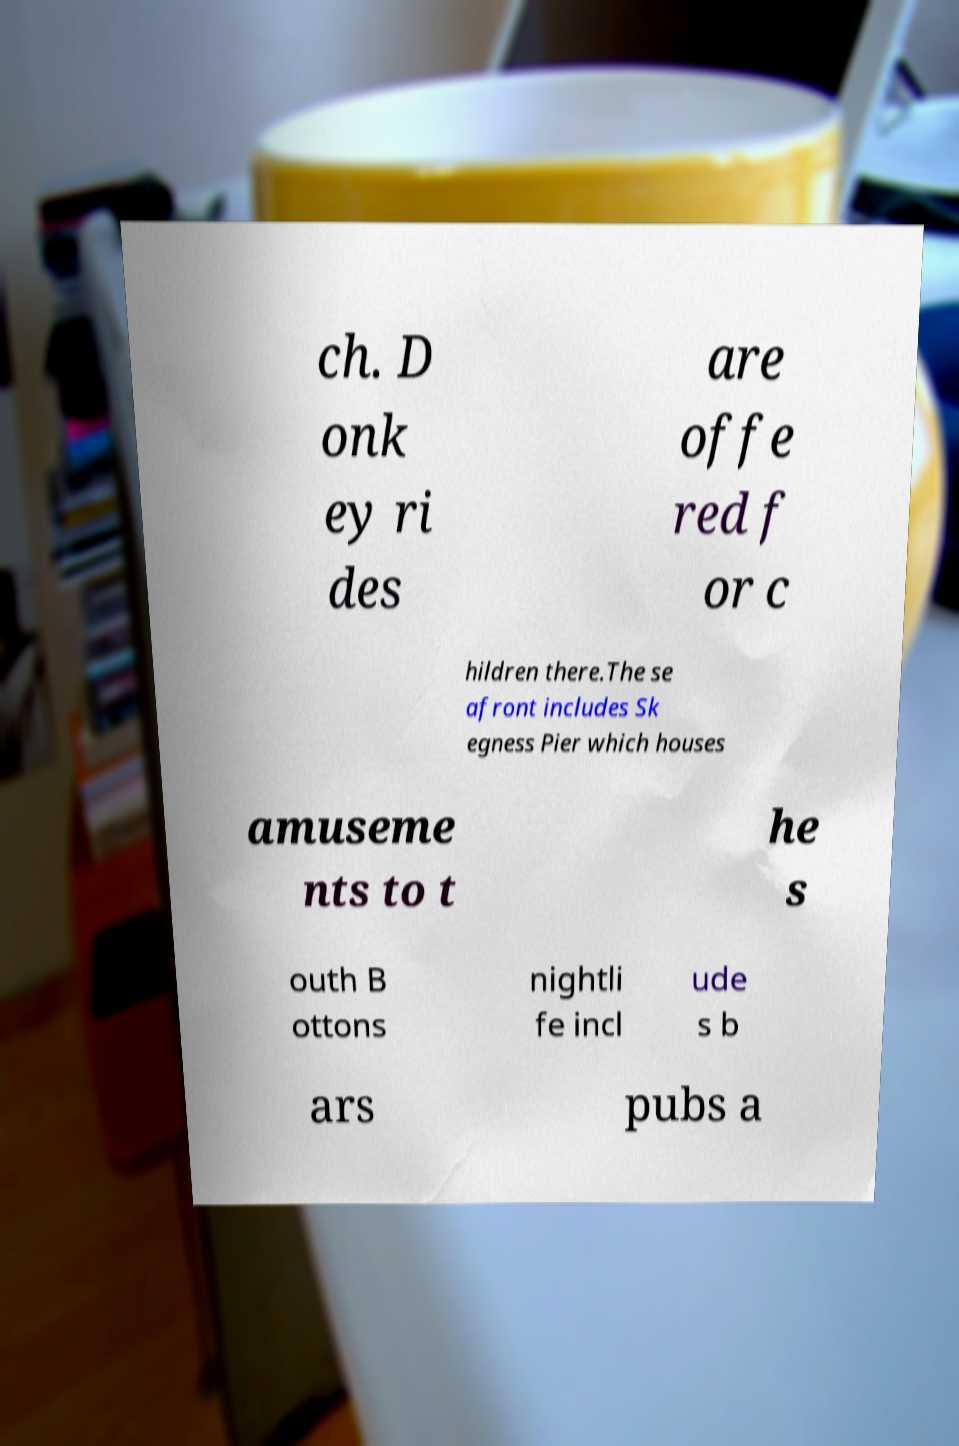Can you accurately transcribe the text from the provided image for me? ch. D onk ey ri des are offe red f or c hildren there.The se afront includes Sk egness Pier which houses amuseme nts to t he s outh B ottons nightli fe incl ude s b ars pubs a 